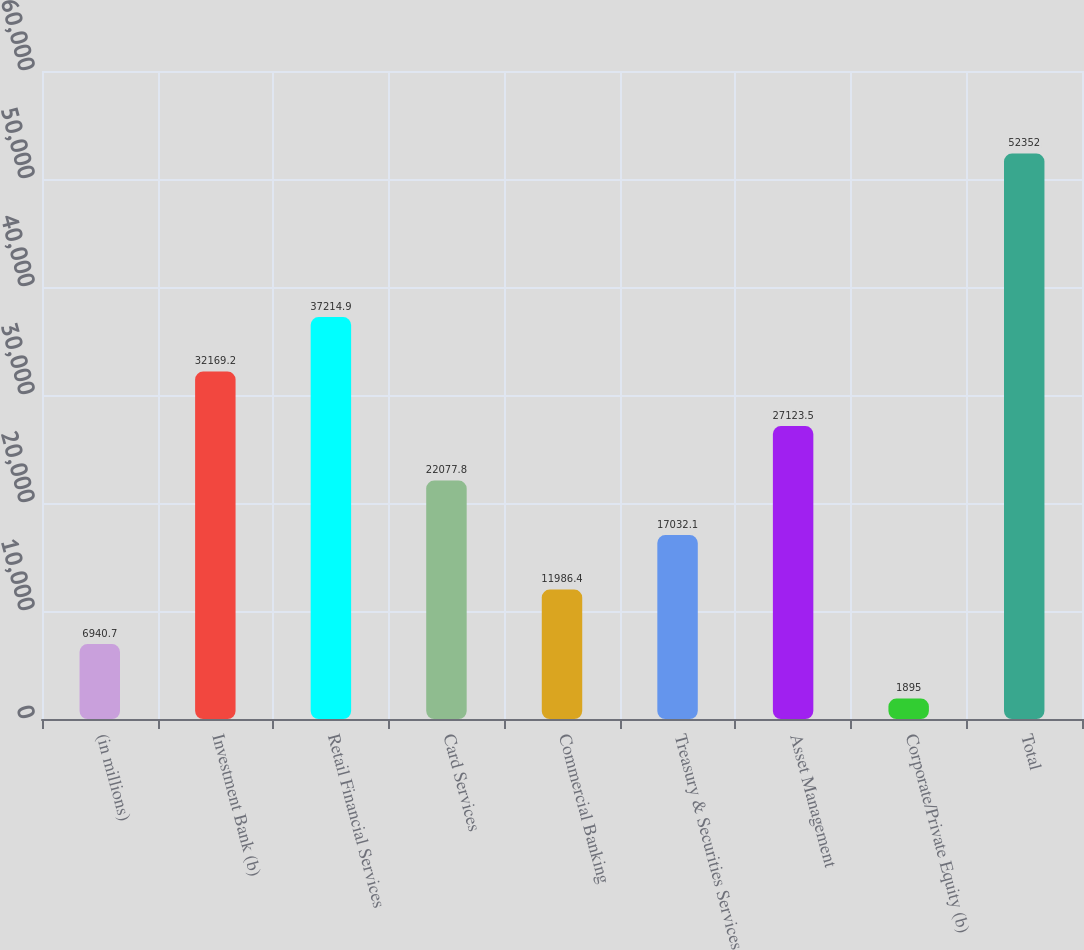Convert chart. <chart><loc_0><loc_0><loc_500><loc_500><bar_chart><fcel>(in millions)<fcel>Investment Bank (b)<fcel>Retail Financial Services<fcel>Card Services<fcel>Commercial Banking<fcel>Treasury & Securities Services<fcel>Asset Management<fcel>Corporate/Private Equity (b)<fcel>Total<nl><fcel>6940.7<fcel>32169.2<fcel>37214.9<fcel>22077.8<fcel>11986.4<fcel>17032.1<fcel>27123.5<fcel>1895<fcel>52352<nl></chart> 